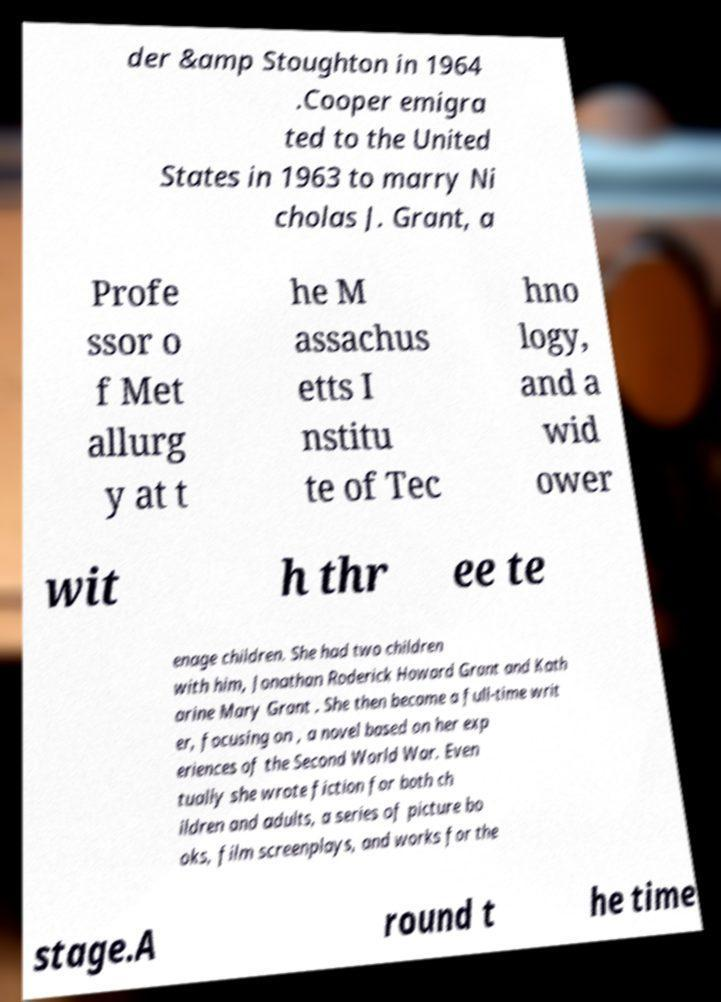Please identify and transcribe the text found in this image. der &amp Stoughton in 1964 .Cooper emigra ted to the United States in 1963 to marry Ni cholas J. Grant, a Profe ssor o f Met allurg y at t he M assachus etts I nstitu te of Tec hno logy, and a wid ower wit h thr ee te enage children. She had two children with him, Jonathan Roderick Howard Grant and Kath arine Mary Grant . She then became a full-time writ er, focusing on , a novel based on her exp eriences of the Second World War. Even tually she wrote fiction for both ch ildren and adults, a series of picture bo oks, film screenplays, and works for the stage.A round t he time 